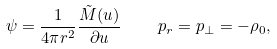<formula> <loc_0><loc_0><loc_500><loc_500>\psi = \frac { 1 } { 4 \pi r ^ { 2 } } \frac { \tilde { M } ( u ) } { \partial u } \quad \ p _ { r } = p _ { \bot } = - \rho _ { 0 } ,</formula> 